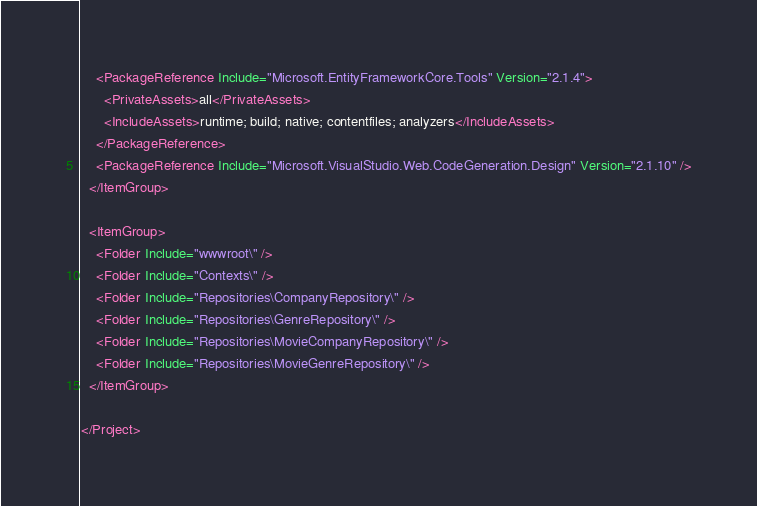Convert code to text. <code><loc_0><loc_0><loc_500><loc_500><_XML_>    <PackageReference Include="Microsoft.EntityFrameworkCore.Tools" Version="2.1.4">
      <PrivateAssets>all</PrivateAssets>
      <IncludeAssets>runtime; build; native; contentfiles; analyzers</IncludeAssets>
    </PackageReference>
    <PackageReference Include="Microsoft.VisualStudio.Web.CodeGeneration.Design" Version="2.1.10" />
  </ItemGroup>

  <ItemGroup>
    <Folder Include="wwwroot\" />
    <Folder Include="Contexts\" />
    <Folder Include="Repositories\CompanyRepository\" />
    <Folder Include="Repositories\GenreRepository\" />
    <Folder Include="Repositories\MovieCompanyRepository\" />
    <Folder Include="Repositories\MovieGenreRepository\" />
  </ItemGroup>

</Project>
</code> 